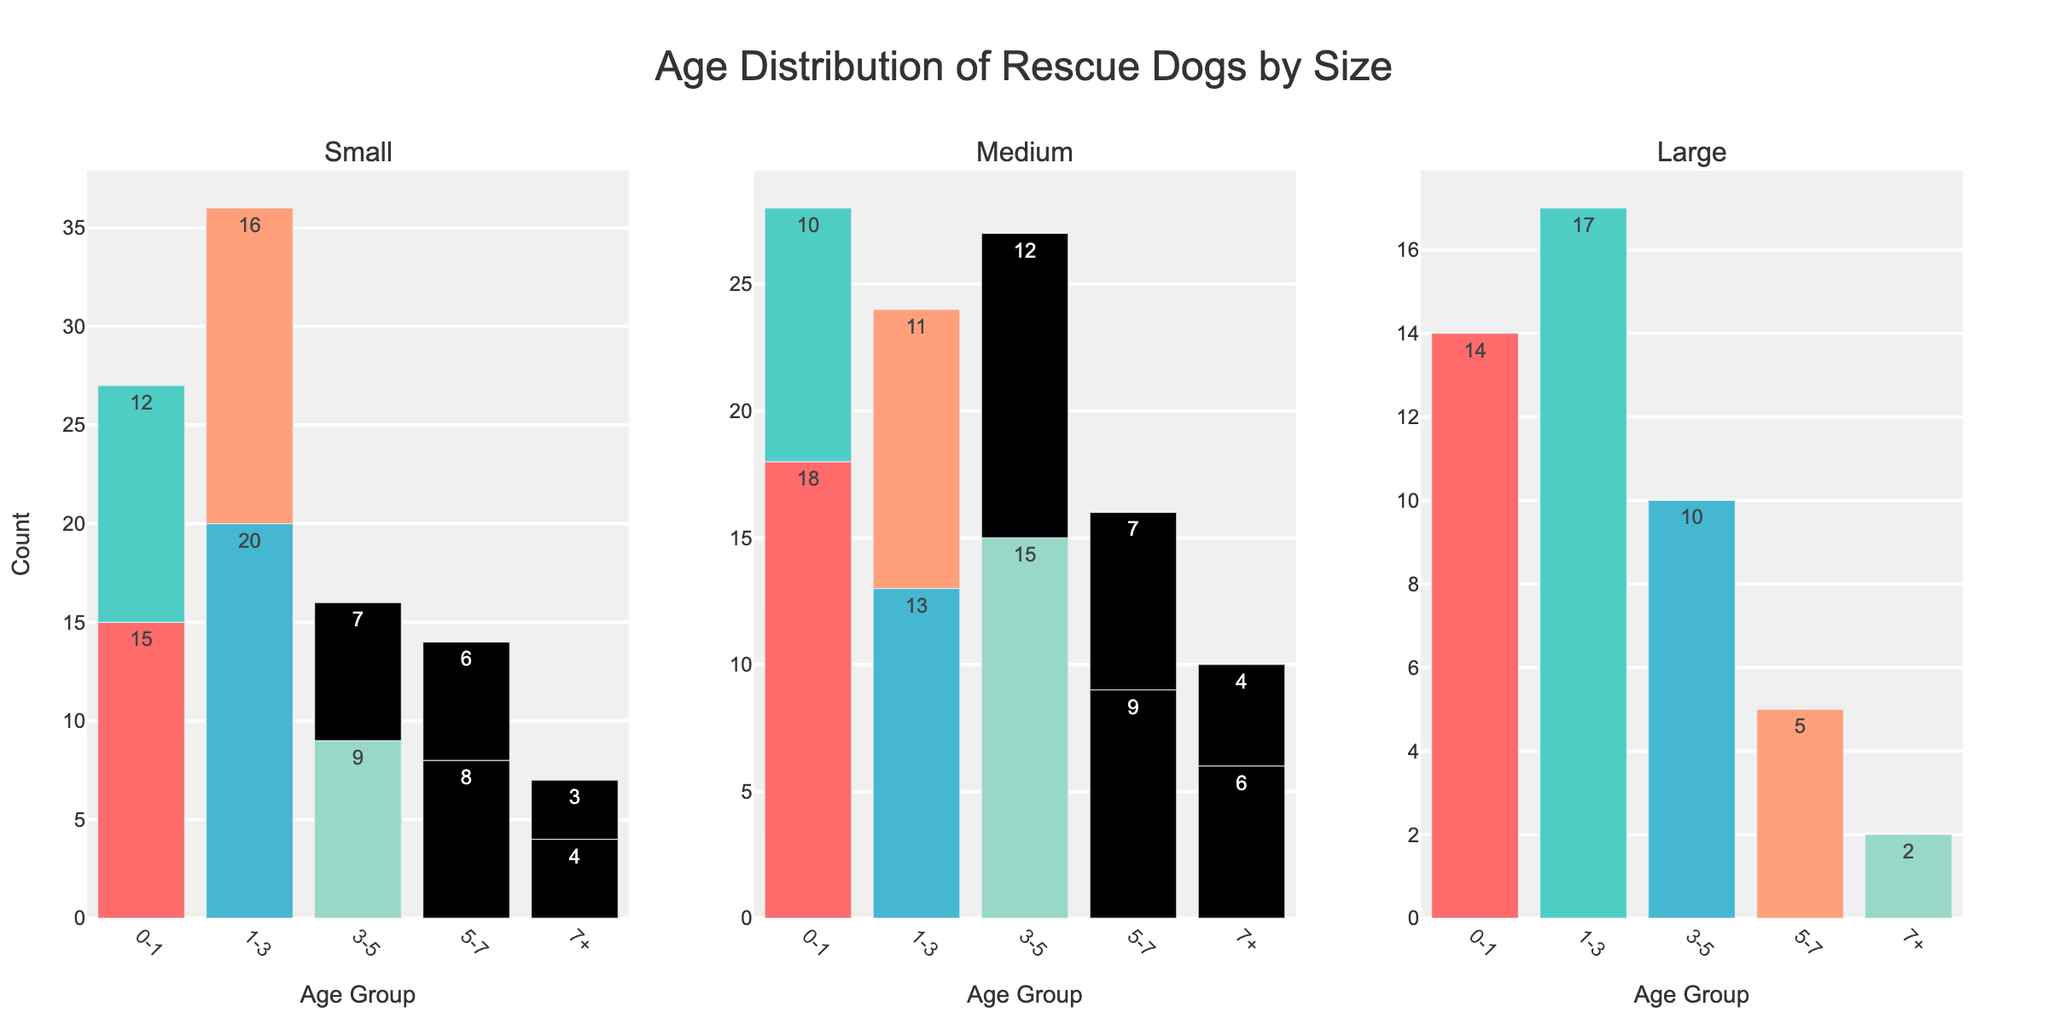Which age group has the highest count for Small breed dogs? Looking at the subplot for Small breed dogs, the bar representing the age group 1-3 has the highest count, which is 20.
Answer: 1-3 What is the total count of Medium breed dogs across all age groups? Summing the counts across all age groups for Medium breed dogs: 18 (0-1) + 13 (1-3) + 15 (3-5) + 9 (5-7) + 6 (7+) = 61.
Answer: 61 How does the count of Large breed dogs aged 7+ compare to Medium breed dogs aged 7+? The count for Large breed dogs aged 7+ is 2, whereas for Medium breed dogs aged 7+ it is 6. Therefore, Medium breed dogs have a higher count in this age group.
Answer: Medium breed dogs have a higher count Which breed size category has the smallest distribution in the 3-5 age group? Observing the subplots for the 3-5 age group, Small breed dogs have lower counts (9 + 7).
Answer: Small Which age group has the lowest count for Large breed dogs? Reviewing the Large breed subplot, the age group 7+ has a count of 2, which is the lowest among all age groups.
Answer: 7+ What is the difference in counts between Small breed dogs aged 0-1 and Large breed dogs aged 0-1? The count for Small breed dogs aged 0-1 is 15 + 12 = 27. The count for Large breed dogs aged 0-1 is 14. The difference is 27 - 14 = 13.
Answer: 13 What is the average count for the age group 1-3 across all breed sizes? First, sum the counts for the 1-3 age group across all breed sizes: 20 (Small) + 16 (Small) + 13 (Medium) + 11 (Medium) + 17 (Large). Total = 77. The average is 77 / 5 = 15.4.
Answer: 15.4 Are there more Small or Large breed dogs aged 3-5? Looking at the figures, Small breed dogs aged 3-5 have counts of 9 + 7 = 16. Large breed dogs aged 3-5 have a count of 10. Therefore, there are more Small breed dogs in this age group.
Answer: Small breed dogs What is the total number of dogs aged 5-7? Adding the counts for all breed sizes in the 5-7 age group: 8 (Small) + 6 (Small) + 9 (Medium) + 7 (Medium) + 5 (Large). Total = 35.
Answer: 35 Which breed size category has the most balanced distribution across age groups? To determine balance, we look for similar counts across different age groups within each subplot. Medium breed dogs have relatively consistent counts: 18 (0-1), 13 (1-3), 15 (3-5), 9 (5-7), 6 (7+), indicating the most balanced distribution.
Answer: Medium 